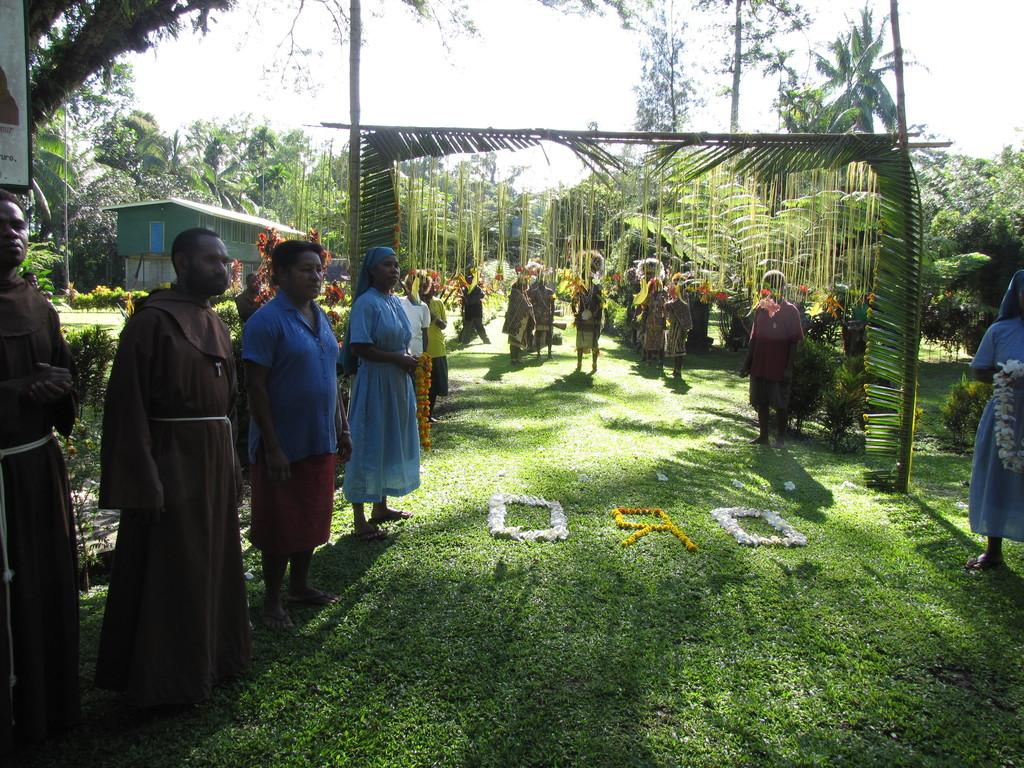What is happening in the image? There is a group of people standing in the image. What can be seen on the ground in the image? There are flowers on the grass in the image. What type of vegetation is present in the image? There are plants and trees in the image. What type of structure is visible in the image? There is a house in the image. What else can be seen in the image besides the people, flowers, plants, trees, and house? There are other items in the image. What is visible in the background of the image? The sky is visible in the background of the image. What type of silk is being used to cover the trees in the image? There is no silk present in the image, and the trees are not covered. What event is happening in the image that led to the death of one of the people? There is no indication of any death or event in the image; it simply shows a group of people standing with various other elements. 